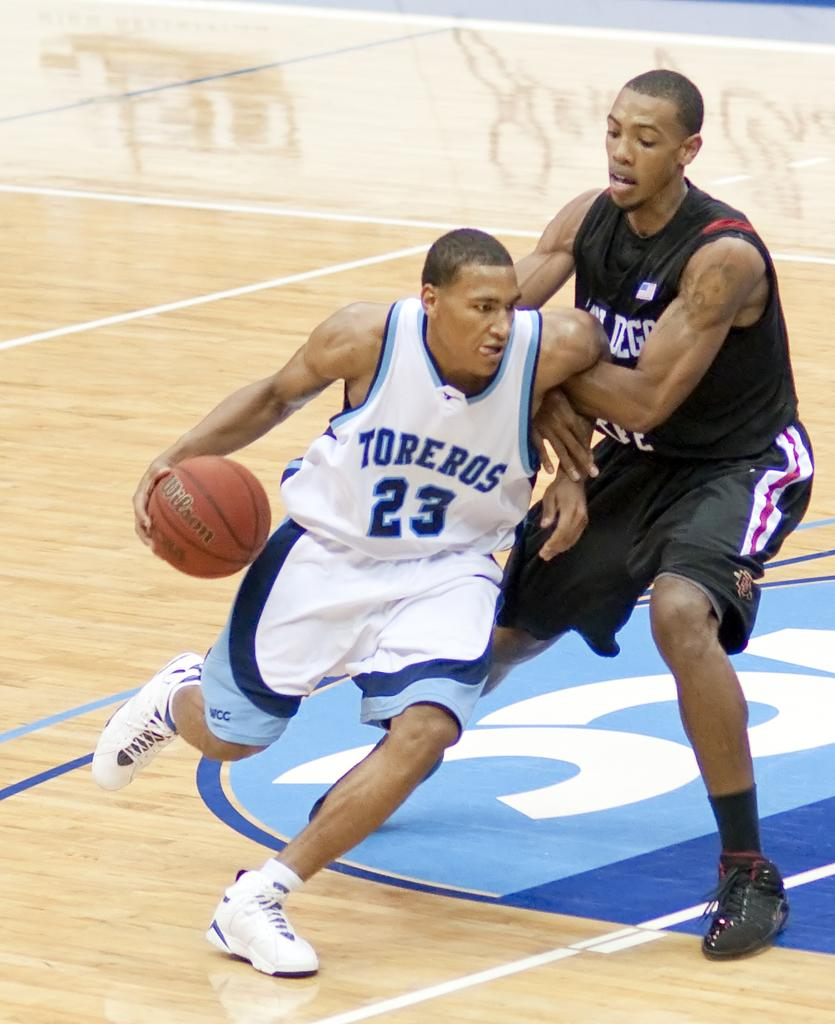<image>
Summarize the visual content of the image. Two men playing basketball, one of them has the word Toreros on their shirt. 